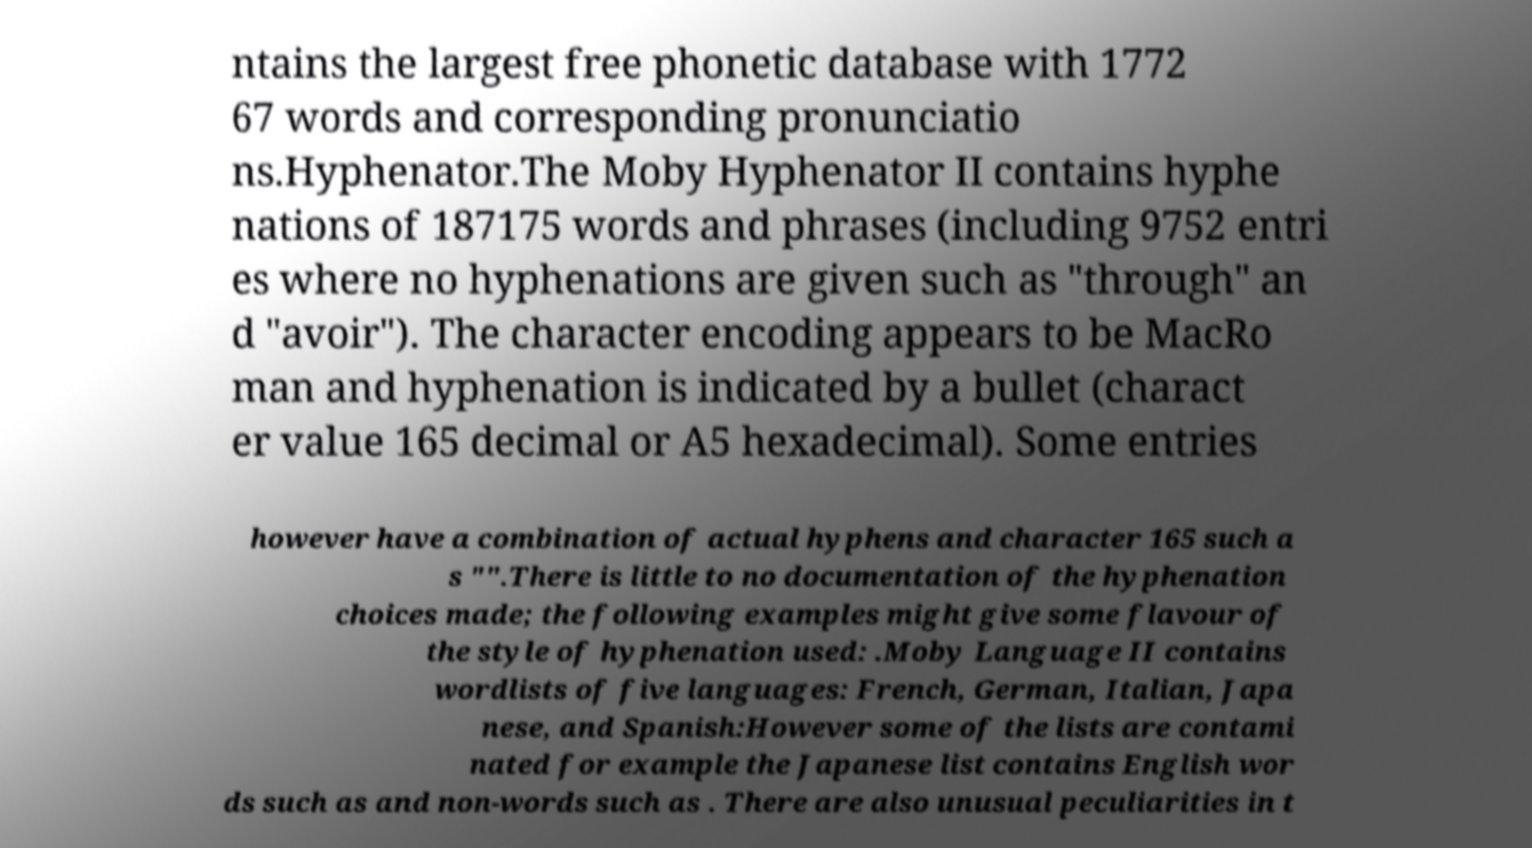Can you read and provide the text displayed in the image?This photo seems to have some interesting text. Can you extract and type it out for me? ntains the largest free phonetic database with 1772 67 words and corresponding pronunciatio ns.Hyphenator.The Moby Hyphenator II contains hyphe nations of 187175 words and phrases (including 9752 entri es where no hyphenations are given such as "through" an d "avoir"). The character encoding appears to be MacRo man and hyphenation is indicated by a bullet (charact er value 165 decimal or A5 hexadecimal). Some entries however have a combination of actual hyphens and character 165 such a s "".There is little to no documentation of the hyphenation choices made; the following examples might give some flavour of the style of hyphenation used: .Moby Language II contains wordlists of five languages: French, German, Italian, Japa nese, and Spanish:However some of the lists are contami nated for example the Japanese list contains English wor ds such as and non-words such as . There are also unusual peculiarities in t 